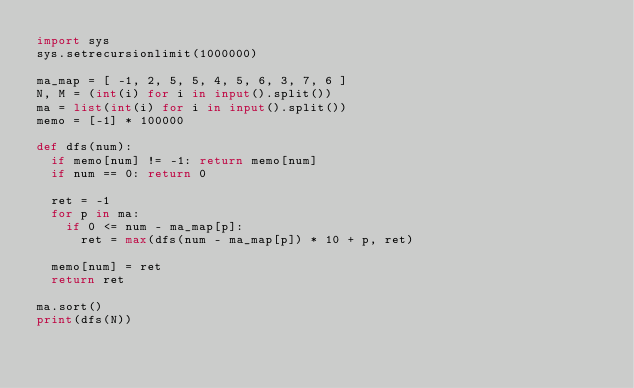<code> <loc_0><loc_0><loc_500><loc_500><_Python_>import sys
sys.setrecursionlimit(1000000)
 
ma_map = [ -1, 2, 5, 5, 4, 5, 6, 3, 7, 6 ]
N, M = (int(i) for i in input().split())
ma = list(int(i) for i in input().split())
memo = [-1] * 100000
 
def dfs(num):
	if memo[num] != -1: return memo[num]
	if num == 0: return 0
 
	ret = -1
	for p in ma:
		if 0 <= num - ma_map[p]:
			ret = max(dfs(num - ma_map[p]) * 10 + p, ret)
 
	memo[num] = ret
	return ret
 
ma.sort()
print(dfs(N))</code> 